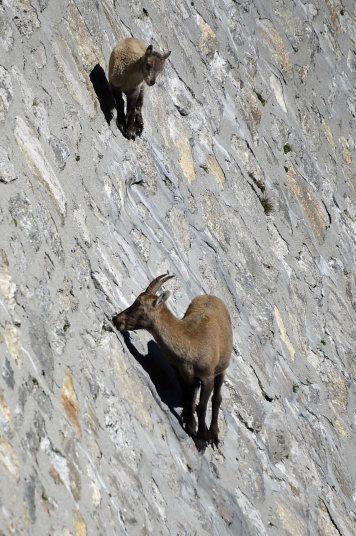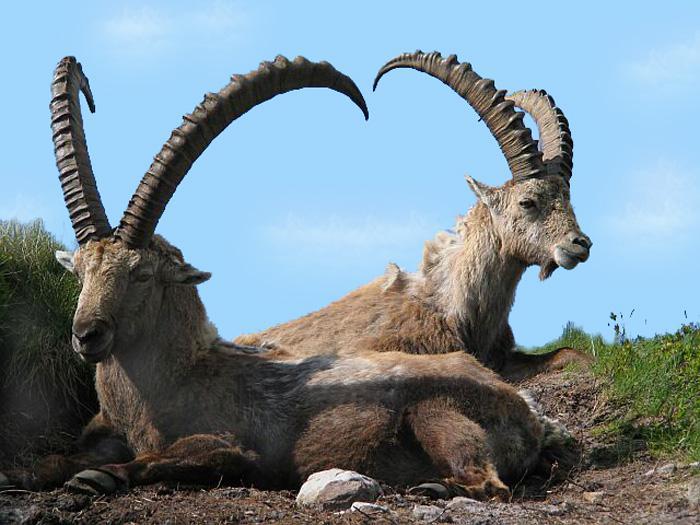The first image is the image on the left, the second image is the image on the right. Examine the images to the left and right. Is the description "There is at least one goat climbing a steep incline." accurate? Answer yes or no. Yes. The first image is the image on the left, the second image is the image on the right. For the images displayed, is the sentence "An ibex has its front paws off the ground." factually correct? Answer yes or no. No. 